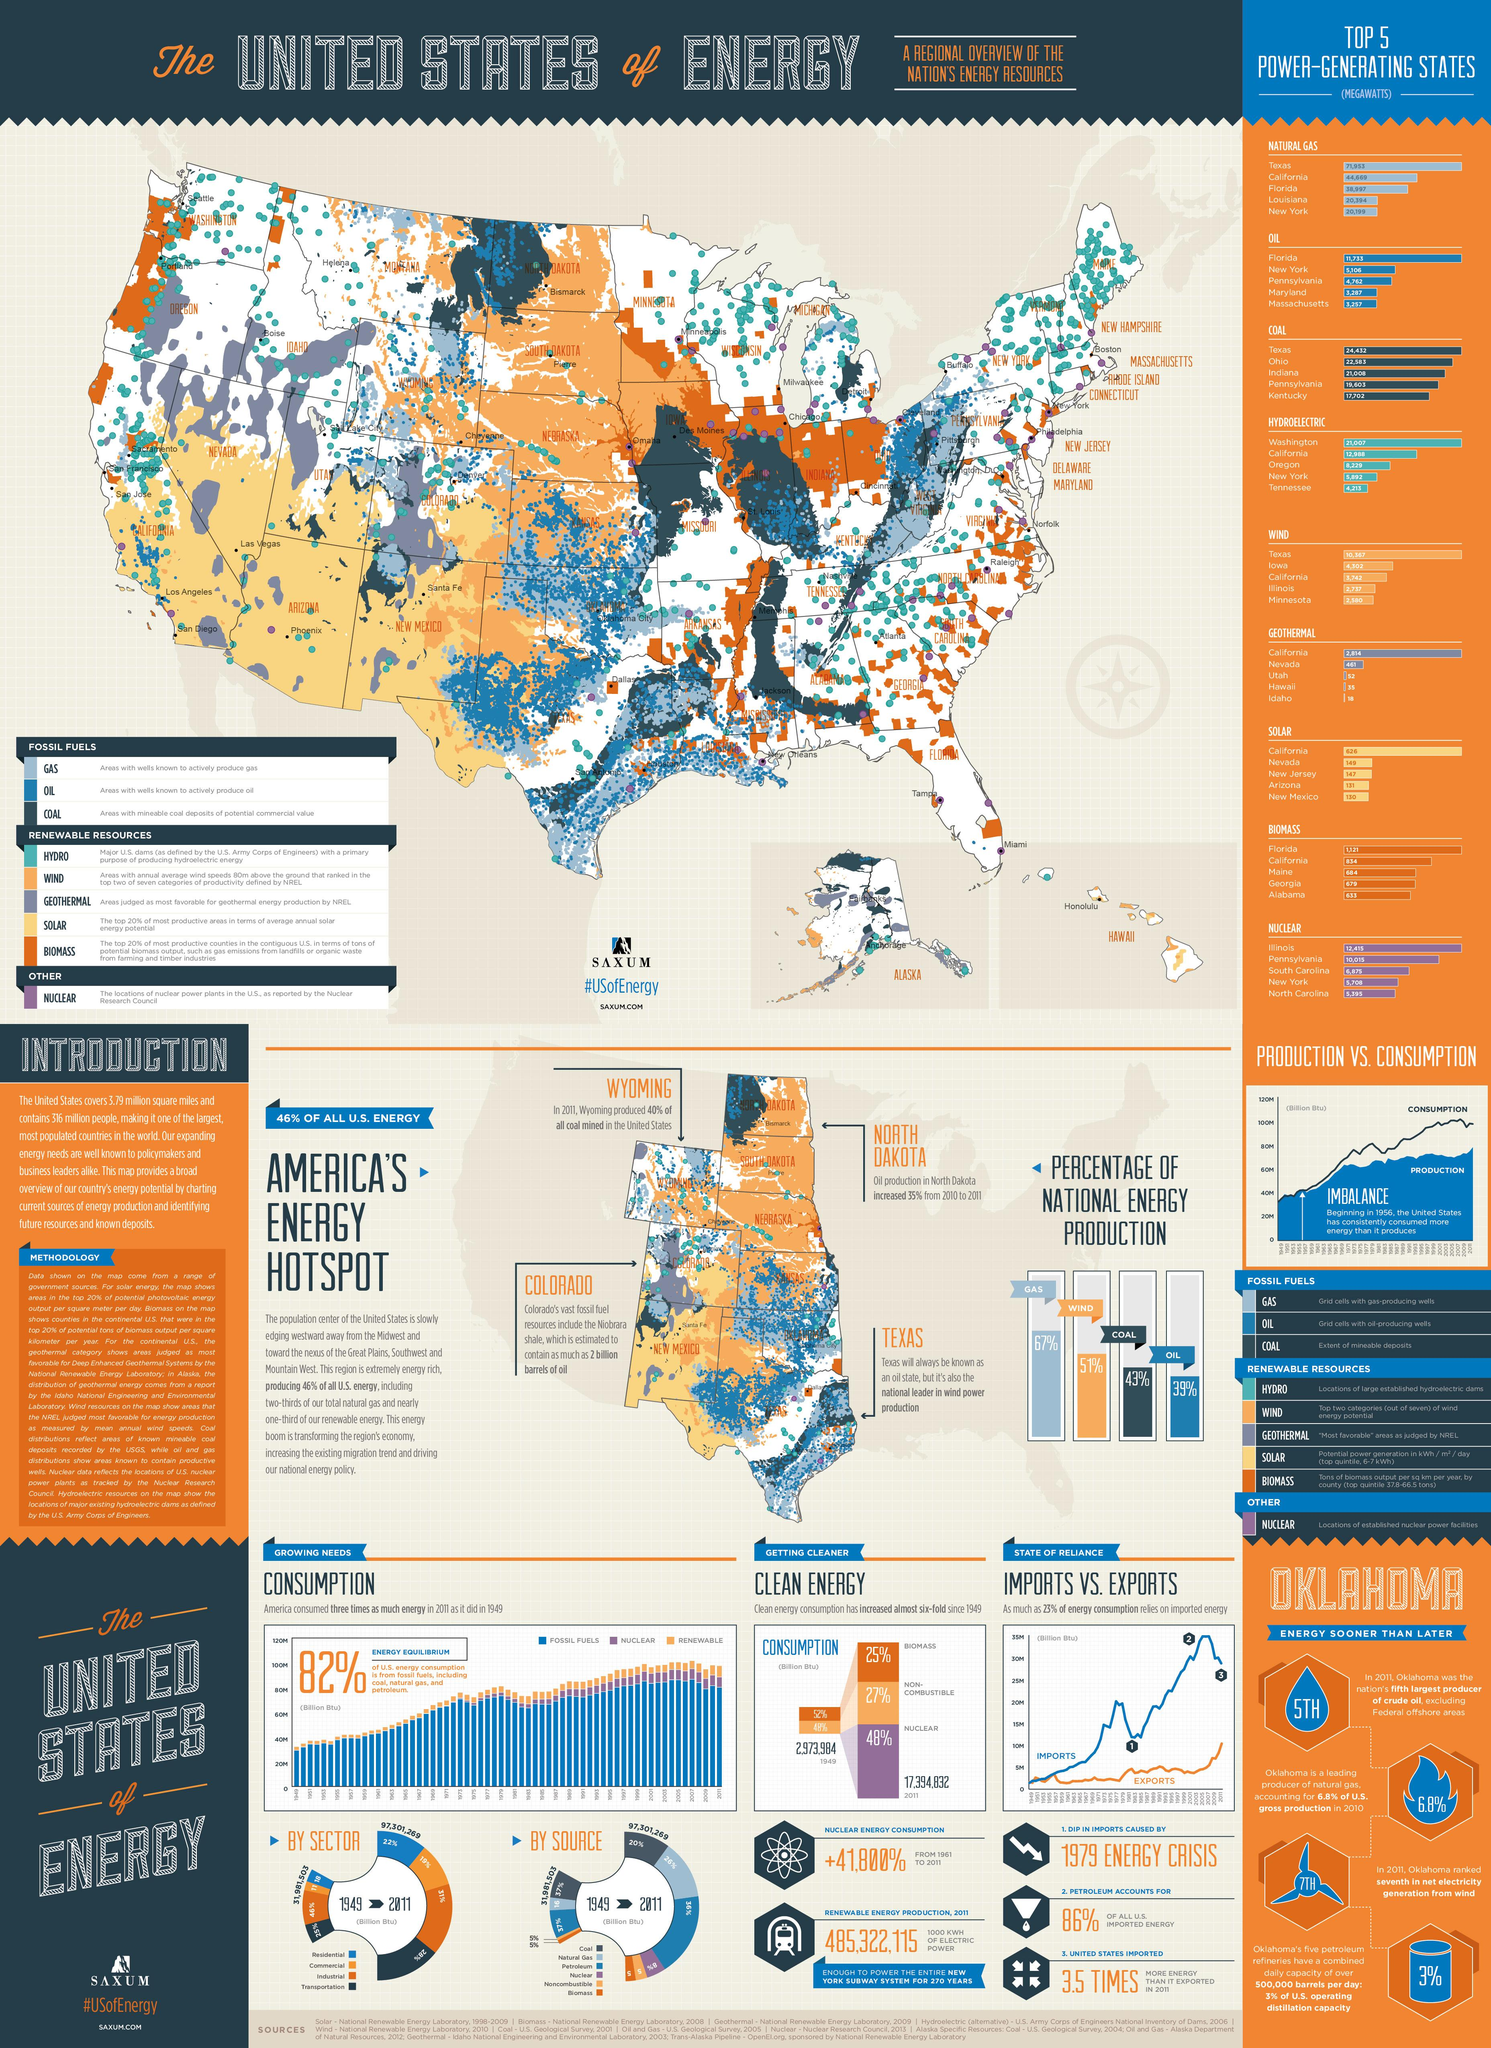Give some essential details in this illustration. The South Western part of America is known for its abundant supply of solar energy, a clean and renewable energy resource that has become increasingly popular in recent years. Coal is the energy source that has the third highest percentage in national energy production. The bar graph with the second highest percentage of national energy production is colored orange. According to national energy production, the least percentage of energy sources comes from oil. According to the table, three types of fossil fuels are listed. 